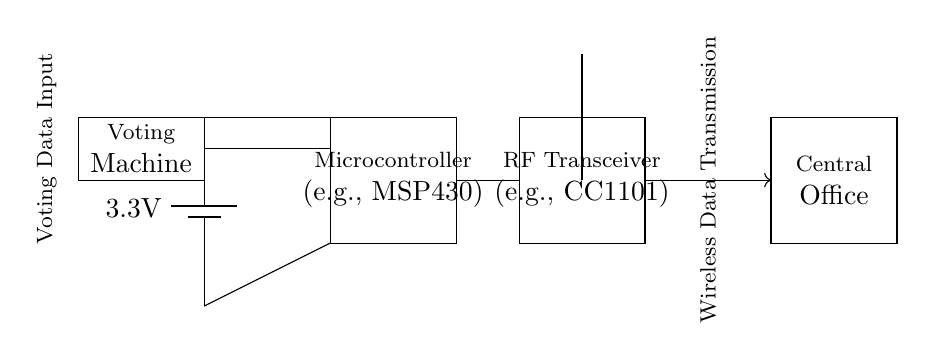What is the voltage of this circuit? The voltage of the circuit is 3.3 volts, which is indicated by the battery symbol in the diagram.
Answer: 3.3 volts What component receives the voting data input? The voting data input is received by the voting machine component, which is shown as a rectangle on the left side of the circuit diagram. This component is connected directly to the microcontroller.
Answer: Voting Machine Which component is responsible for wireless transmission? The RF transceiver, labeled in the diagram, is responsible for wireless transmission and is represented as a rectangle near the antenna.
Answer: RF Transceiver What is the purpose of the microcontroller in this circuit? The microcontroller processes the voting data, as indicated by its labeling in the diagram. It connects the voting machine input to the RF transceiver for data transmission.
Answer: Data Processing How does the RF transceiver connect to the microcontroller? The RF transceiver connects to the microcontroller via a direct line, which shows that it receives the processed data for transmission. This is depicted in the circuit with a straight line connecting the two components.
Answer: Direct Line Why is low power operation important in this voting circuit? Low power operation is crucial to ensure that the circuit runs efficiently without draining battery resources quickly, which is particularly important for devices like voting machines that may need to operate for extended periods without external power supplies.
Answer: Energy Efficiency 